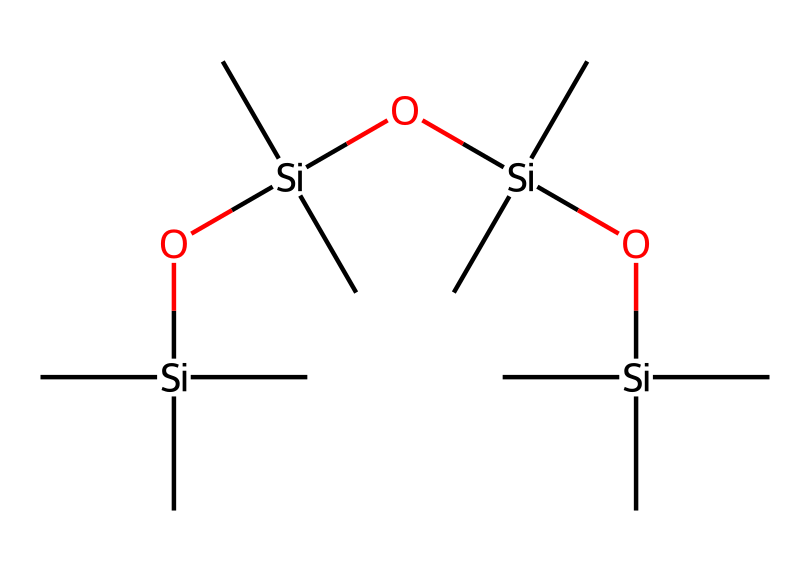What type of chemical structure is represented by the provided SMILES? The SMILES structure indicates a linear arrangement of silicon atoms connected by oxygen atoms (Si-O bonds) with methyl groups attached (C). This reflects the siloxane structure characteristic of organosilicon compounds.
Answer: siloxane How many silicon atoms are present in the structure? By analyzing the SMILES representation, we can see that the core structure contains four silicon atoms indicated by 'Si'. Count each 'Si' to find the total number.
Answer: 4 What is the main component that provides lubrication in this chemical? The presence of silicon (Si) atoms and the connectivity to oxygen (O) and methyl groups (C) suggest that the siloxane segments are responsible for the lubricant properties due to their flexibility and low surface tension.
Answer: siloxane segments How many oxygen atoms are present in the compound? In the provided SMILES, the sequence 'O' appears three times, indicating the presence of three oxygen atoms linking the silicon atoms in the structure.
Answer: 3 Which functional group is primarily responsible for the chemical's properties as a lubricant? The siloxane (-Si-O-Si-) linkages create a flexible and low-viscosity fluid, which are characteristics expected from lubricants. These properties arise primarily from the siloxane groups in the chemical structure.
Answer: siloxane groups What kind of interactions are likely present due to the methyl groups in this compound? The methyl (C) groups provide hydrophobic interactions and reduce surface tension, aiding in lubrication effectiveness. This is a common property in organosilicon compounds, enhancing their functionality in sports equipment.
Answer: hydrophobic interactions 